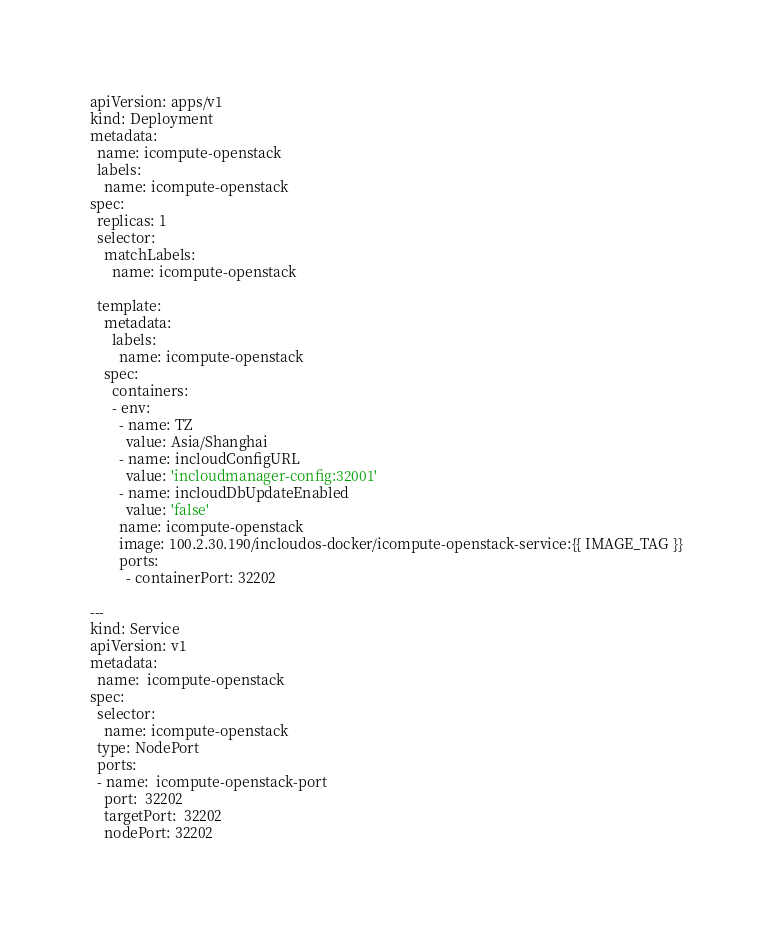<code> <loc_0><loc_0><loc_500><loc_500><_YAML_>apiVersion: apps/v1
kind: Deployment
metadata:
  name: icompute-openstack
  labels:
    name: icompute-openstack
spec:
  replicas: 1
  selector:
    matchLabels:
      name: icompute-openstack

  template:
    metadata:
      labels:
        name: icompute-openstack
    spec:
      containers:
      - env:
        - name: TZ
          value: Asia/Shanghai
        - name: incloudConfigURL
          value: 'incloudmanager-config:32001'
        - name: incloudDbUpdateEnabled
          value: 'false'
        name: icompute-openstack
        image: 100.2.30.190/incloudos-docker/icompute-openstack-service:{{ IMAGE_TAG }}
        ports:
          - containerPort: 32202

---
kind: Service
apiVersion: v1
metadata:
  name:  icompute-openstack
spec:
  selector:
    name: icompute-openstack
  type: NodePort
  ports:
  - name:  icompute-openstack-port
    port:  32202
    targetPort:  32202
    nodePort: 32202
</code> 